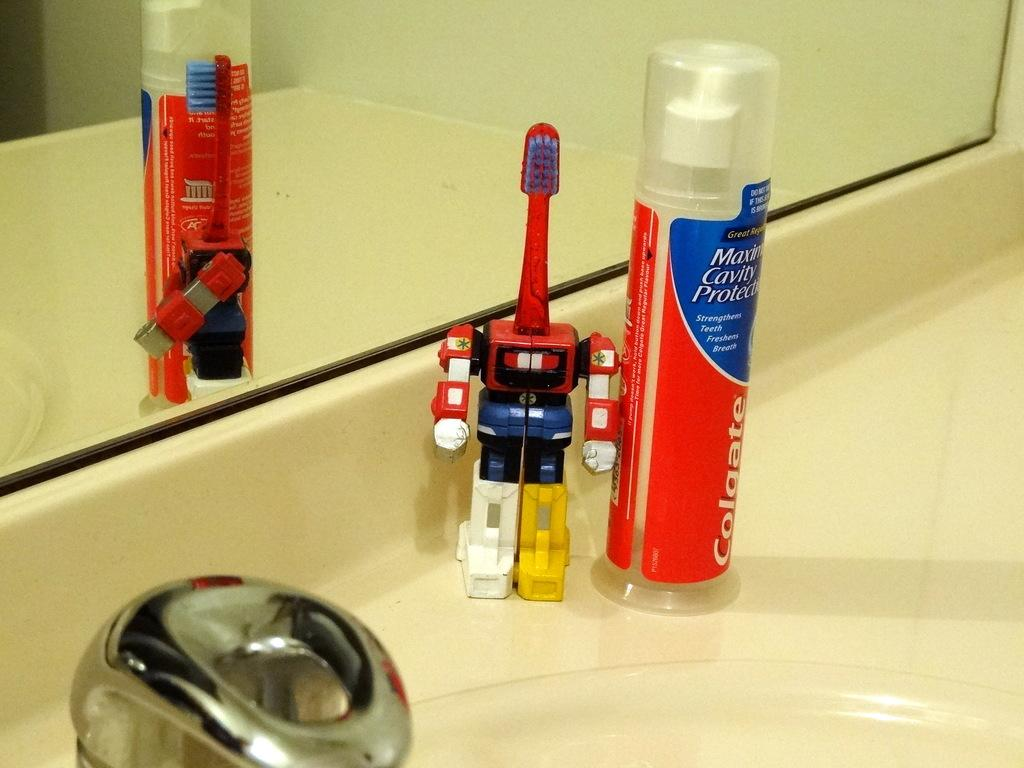What object can be seen in the image that is typically used for cleaning or grooming? There is a brush in the image. What other object is present in the image that is often used with the brush? There is a bottle in the image. Where are the brush and bottle located in the image? The brush and bottle are on a white surface. What feature is present in the image that is commonly used for washing or rinsing? There is a tap in the image. What can be seen in the background of the image that is typically used for personal grooming or checking one's appearance? There is a mirror in the background of the image. Can you tell me how many partners are playing with the brush and bottle in the image? There are no partners present in the image, as it only features a brush, a bottle, and a white surface. 